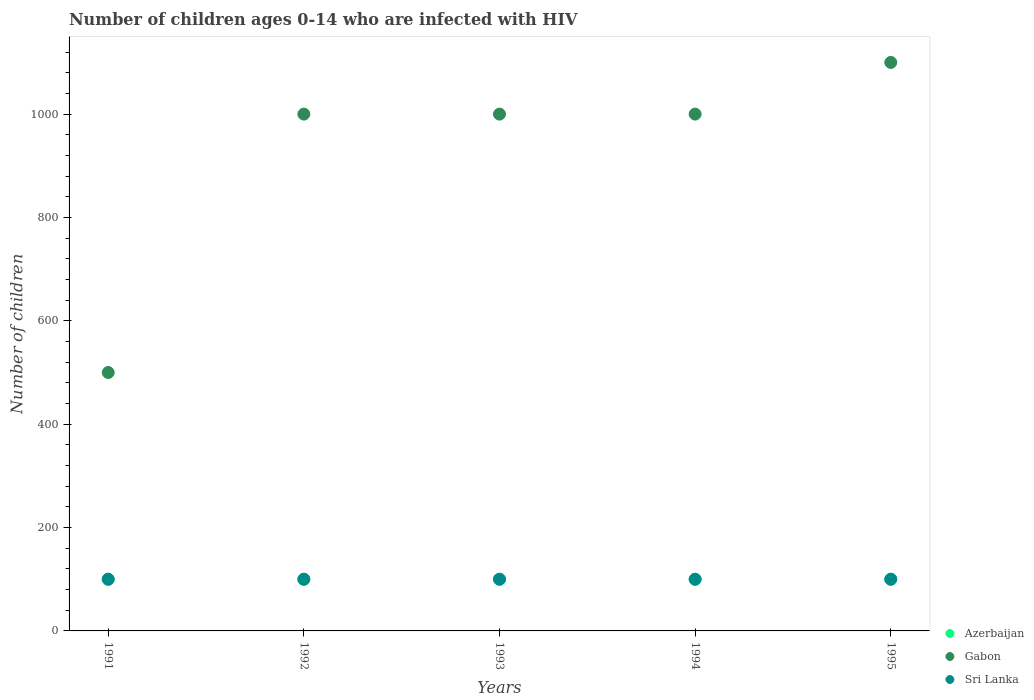How many different coloured dotlines are there?
Your response must be concise. 3. Is the number of dotlines equal to the number of legend labels?
Offer a terse response. Yes. What is the number of HIV infected children in Azerbaijan in 1995?
Provide a short and direct response. 100. Across all years, what is the maximum number of HIV infected children in Gabon?
Your answer should be compact. 1100. Across all years, what is the minimum number of HIV infected children in Azerbaijan?
Provide a short and direct response. 100. In which year was the number of HIV infected children in Gabon maximum?
Offer a terse response. 1995. In which year was the number of HIV infected children in Gabon minimum?
Ensure brevity in your answer.  1991. What is the total number of HIV infected children in Azerbaijan in the graph?
Keep it short and to the point. 500. What is the difference between the number of HIV infected children in Azerbaijan in 1993 and that in 1994?
Your answer should be compact. 0. What is the difference between the number of HIV infected children in Gabon in 1994 and the number of HIV infected children in Sri Lanka in 1992?
Your answer should be very brief. 900. What is the average number of HIV infected children in Gabon per year?
Provide a short and direct response. 920. In the year 1995, what is the difference between the number of HIV infected children in Gabon and number of HIV infected children in Azerbaijan?
Provide a short and direct response. 1000. Is the number of HIV infected children in Gabon in 1992 less than that in 1995?
Give a very brief answer. Yes. What is the difference between the highest and the second highest number of HIV infected children in Sri Lanka?
Give a very brief answer. 0. What is the difference between the highest and the lowest number of HIV infected children in Gabon?
Keep it short and to the point. 600. In how many years, is the number of HIV infected children in Sri Lanka greater than the average number of HIV infected children in Sri Lanka taken over all years?
Provide a short and direct response. 0. Does the number of HIV infected children in Sri Lanka monotonically increase over the years?
Give a very brief answer. No. Is the number of HIV infected children in Sri Lanka strictly less than the number of HIV infected children in Gabon over the years?
Provide a succinct answer. Yes. How many dotlines are there?
Offer a terse response. 3. How many years are there in the graph?
Ensure brevity in your answer.  5. How many legend labels are there?
Make the answer very short. 3. What is the title of the graph?
Offer a terse response. Number of children ages 0-14 who are infected with HIV. What is the label or title of the Y-axis?
Give a very brief answer. Number of children. What is the Number of children of Azerbaijan in 1991?
Offer a terse response. 100. What is the Number of children of Sri Lanka in 1991?
Offer a terse response. 100. What is the Number of children in Gabon in 1992?
Provide a short and direct response. 1000. What is the Number of children of Sri Lanka in 1993?
Provide a succinct answer. 100. What is the Number of children of Gabon in 1994?
Ensure brevity in your answer.  1000. What is the Number of children of Gabon in 1995?
Your response must be concise. 1100. Across all years, what is the maximum Number of children of Gabon?
Give a very brief answer. 1100. Across all years, what is the maximum Number of children in Sri Lanka?
Give a very brief answer. 100. Across all years, what is the minimum Number of children in Gabon?
Your response must be concise. 500. Across all years, what is the minimum Number of children of Sri Lanka?
Offer a very short reply. 100. What is the total Number of children in Gabon in the graph?
Give a very brief answer. 4600. What is the total Number of children in Sri Lanka in the graph?
Give a very brief answer. 500. What is the difference between the Number of children in Azerbaijan in 1991 and that in 1992?
Make the answer very short. 0. What is the difference between the Number of children of Gabon in 1991 and that in 1992?
Your response must be concise. -500. What is the difference between the Number of children of Azerbaijan in 1991 and that in 1993?
Offer a terse response. 0. What is the difference between the Number of children in Gabon in 1991 and that in 1993?
Ensure brevity in your answer.  -500. What is the difference between the Number of children of Sri Lanka in 1991 and that in 1993?
Provide a short and direct response. 0. What is the difference between the Number of children in Gabon in 1991 and that in 1994?
Your response must be concise. -500. What is the difference between the Number of children in Sri Lanka in 1991 and that in 1994?
Provide a succinct answer. 0. What is the difference between the Number of children in Gabon in 1991 and that in 1995?
Your response must be concise. -600. What is the difference between the Number of children in Sri Lanka in 1991 and that in 1995?
Provide a succinct answer. 0. What is the difference between the Number of children of Sri Lanka in 1992 and that in 1993?
Provide a short and direct response. 0. What is the difference between the Number of children in Azerbaijan in 1992 and that in 1994?
Keep it short and to the point. 0. What is the difference between the Number of children of Gabon in 1992 and that in 1994?
Offer a very short reply. 0. What is the difference between the Number of children of Azerbaijan in 1992 and that in 1995?
Provide a short and direct response. 0. What is the difference between the Number of children of Gabon in 1992 and that in 1995?
Keep it short and to the point. -100. What is the difference between the Number of children of Sri Lanka in 1993 and that in 1994?
Your answer should be very brief. 0. What is the difference between the Number of children in Gabon in 1993 and that in 1995?
Your response must be concise. -100. What is the difference between the Number of children in Azerbaijan in 1994 and that in 1995?
Make the answer very short. 0. What is the difference between the Number of children in Gabon in 1994 and that in 1995?
Offer a terse response. -100. What is the difference between the Number of children in Sri Lanka in 1994 and that in 1995?
Provide a short and direct response. 0. What is the difference between the Number of children of Azerbaijan in 1991 and the Number of children of Gabon in 1992?
Your answer should be compact. -900. What is the difference between the Number of children in Azerbaijan in 1991 and the Number of children in Sri Lanka in 1992?
Make the answer very short. 0. What is the difference between the Number of children of Azerbaijan in 1991 and the Number of children of Gabon in 1993?
Offer a terse response. -900. What is the difference between the Number of children of Azerbaijan in 1991 and the Number of children of Sri Lanka in 1993?
Your answer should be compact. 0. What is the difference between the Number of children in Azerbaijan in 1991 and the Number of children in Gabon in 1994?
Ensure brevity in your answer.  -900. What is the difference between the Number of children of Gabon in 1991 and the Number of children of Sri Lanka in 1994?
Keep it short and to the point. 400. What is the difference between the Number of children in Azerbaijan in 1991 and the Number of children in Gabon in 1995?
Make the answer very short. -1000. What is the difference between the Number of children of Azerbaijan in 1991 and the Number of children of Sri Lanka in 1995?
Provide a short and direct response. 0. What is the difference between the Number of children in Azerbaijan in 1992 and the Number of children in Gabon in 1993?
Provide a succinct answer. -900. What is the difference between the Number of children in Azerbaijan in 1992 and the Number of children in Sri Lanka in 1993?
Ensure brevity in your answer.  0. What is the difference between the Number of children of Gabon in 1992 and the Number of children of Sri Lanka in 1993?
Provide a short and direct response. 900. What is the difference between the Number of children of Azerbaijan in 1992 and the Number of children of Gabon in 1994?
Ensure brevity in your answer.  -900. What is the difference between the Number of children in Azerbaijan in 1992 and the Number of children in Sri Lanka in 1994?
Make the answer very short. 0. What is the difference between the Number of children in Gabon in 1992 and the Number of children in Sri Lanka in 1994?
Offer a very short reply. 900. What is the difference between the Number of children in Azerbaijan in 1992 and the Number of children in Gabon in 1995?
Ensure brevity in your answer.  -1000. What is the difference between the Number of children of Gabon in 1992 and the Number of children of Sri Lanka in 1995?
Provide a succinct answer. 900. What is the difference between the Number of children of Azerbaijan in 1993 and the Number of children of Gabon in 1994?
Offer a terse response. -900. What is the difference between the Number of children in Azerbaijan in 1993 and the Number of children in Sri Lanka in 1994?
Ensure brevity in your answer.  0. What is the difference between the Number of children in Gabon in 1993 and the Number of children in Sri Lanka in 1994?
Keep it short and to the point. 900. What is the difference between the Number of children in Azerbaijan in 1993 and the Number of children in Gabon in 1995?
Keep it short and to the point. -1000. What is the difference between the Number of children of Azerbaijan in 1993 and the Number of children of Sri Lanka in 1995?
Your answer should be very brief. 0. What is the difference between the Number of children in Gabon in 1993 and the Number of children in Sri Lanka in 1995?
Offer a very short reply. 900. What is the difference between the Number of children in Azerbaijan in 1994 and the Number of children in Gabon in 1995?
Offer a terse response. -1000. What is the difference between the Number of children of Gabon in 1994 and the Number of children of Sri Lanka in 1995?
Ensure brevity in your answer.  900. What is the average Number of children of Azerbaijan per year?
Keep it short and to the point. 100. What is the average Number of children in Gabon per year?
Your response must be concise. 920. In the year 1991, what is the difference between the Number of children in Azerbaijan and Number of children in Gabon?
Provide a succinct answer. -400. In the year 1992, what is the difference between the Number of children in Azerbaijan and Number of children in Gabon?
Your answer should be compact. -900. In the year 1992, what is the difference between the Number of children of Gabon and Number of children of Sri Lanka?
Provide a short and direct response. 900. In the year 1993, what is the difference between the Number of children in Azerbaijan and Number of children in Gabon?
Offer a terse response. -900. In the year 1993, what is the difference between the Number of children in Azerbaijan and Number of children in Sri Lanka?
Your answer should be very brief. 0. In the year 1993, what is the difference between the Number of children in Gabon and Number of children in Sri Lanka?
Your response must be concise. 900. In the year 1994, what is the difference between the Number of children of Azerbaijan and Number of children of Gabon?
Keep it short and to the point. -900. In the year 1994, what is the difference between the Number of children in Gabon and Number of children in Sri Lanka?
Keep it short and to the point. 900. In the year 1995, what is the difference between the Number of children in Azerbaijan and Number of children in Gabon?
Give a very brief answer. -1000. In the year 1995, what is the difference between the Number of children in Gabon and Number of children in Sri Lanka?
Provide a short and direct response. 1000. What is the ratio of the Number of children of Gabon in 1991 to that in 1992?
Your answer should be very brief. 0.5. What is the ratio of the Number of children of Sri Lanka in 1991 to that in 1992?
Provide a succinct answer. 1. What is the ratio of the Number of children in Azerbaijan in 1991 to that in 1993?
Your answer should be compact. 1. What is the ratio of the Number of children of Gabon in 1991 to that in 1994?
Your response must be concise. 0.5. What is the ratio of the Number of children in Sri Lanka in 1991 to that in 1994?
Provide a short and direct response. 1. What is the ratio of the Number of children of Gabon in 1991 to that in 1995?
Offer a very short reply. 0.45. What is the ratio of the Number of children of Gabon in 1992 to that in 1993?
Provide a short and direct response. 1. What is the ratio of the Number of children in Azerbaijan in 1992 to that in 1994?
Your answer should be very brief. 1. What is the ratio of the Number of children of Gabon in 1992 to that in 1994?
Your answer should be very brief. 1. What is the ratio of the Number of children of Sri Lanka in 1992 to that in 1994?
Provide a succinct answer. 1. What is the ratio of the Number of children in Azerbaijan in 1992 to that in 1995?
Ensure brevity in your answer.  1. What is the ratio of the Number of children in Gabon in 1992 to that in 1995?
Make the answer very short. 0.91. What is the ratio of the Number of children of Sri Lanka in 1992 to that in 1995?
Keep it short and to the point. 1. What is the ratio of the Number of children of Azerbaijan in 1993 to that in 1994?
Give a very brief answer. 1. What is the ratio of the Number of children of Sri Lanka in 1993 to that in 1994?
Provide a succinct answer. 1. What is the ratio of the Number of children of Azerbaijan in 1993 to that in 1995?
Make the answer very short. 1. What is the ratio of the Number of children of Gabon in 1994 to that in 1995?
Your answer should be compact. 0.91. What is the ratio of the Number of children in Sri Lanka in 1994 to that in 1995?
Ensure brevity in your answer.  1. What is the difference between the highest and the lowest Number of children in Gabon?
Provide a short and direct response. 600. 